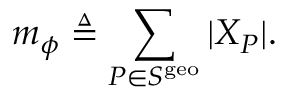Convert formula to latex. <formula><loc_0><loc_0><loc_500><loc_500>m _ { \phi } \triangle q \sum _ { P \in S ^ { g e o } } | X _ { P } | .</formula> 